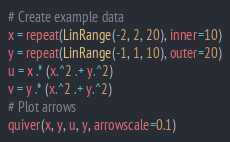<code> <loc_0><loc_0><loc_500><loc_500><_Julia_># Create example data
x = repeat(LinRange(-2, 2, 20), inner=10)
y = repeat(LinRange(-1, 1, 10), outer=20)
u = x .* (x.^2 .+ y.^2)
v = y .* (x.^2 .+ y.^2)
# Plot arrows
quiver(x, y, u, y, arrowscale=0.1)
</code> 